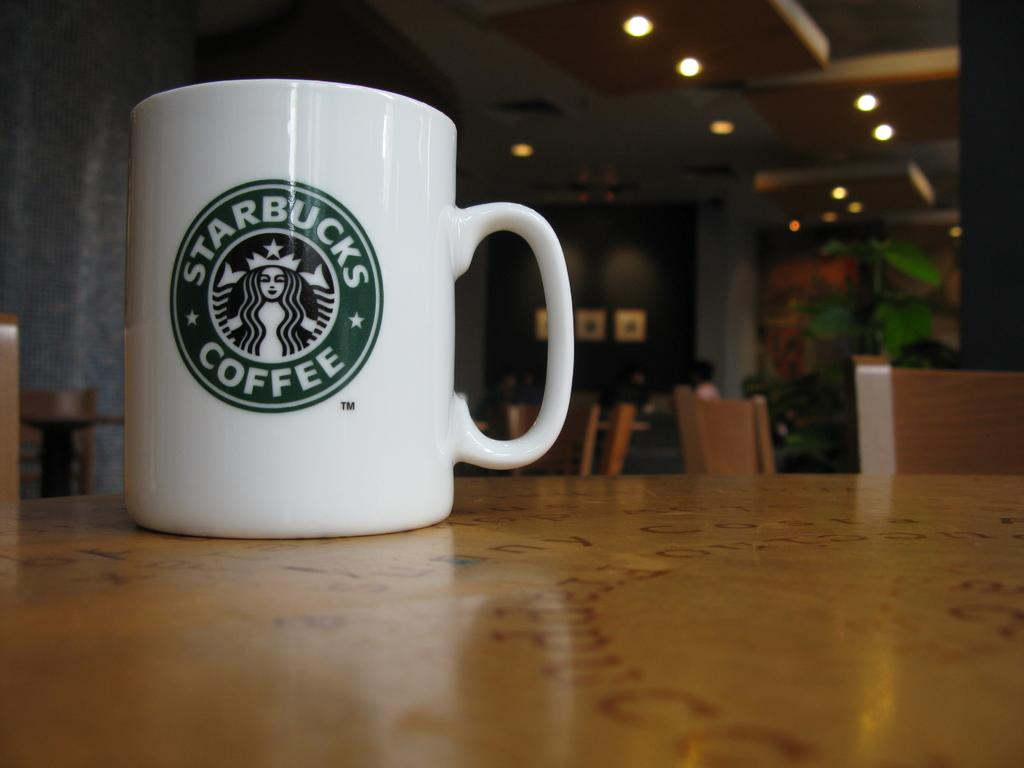<image>
Present a compact description of the photo's key features. A Starbucks Coffee mug sits at on an empty table. 